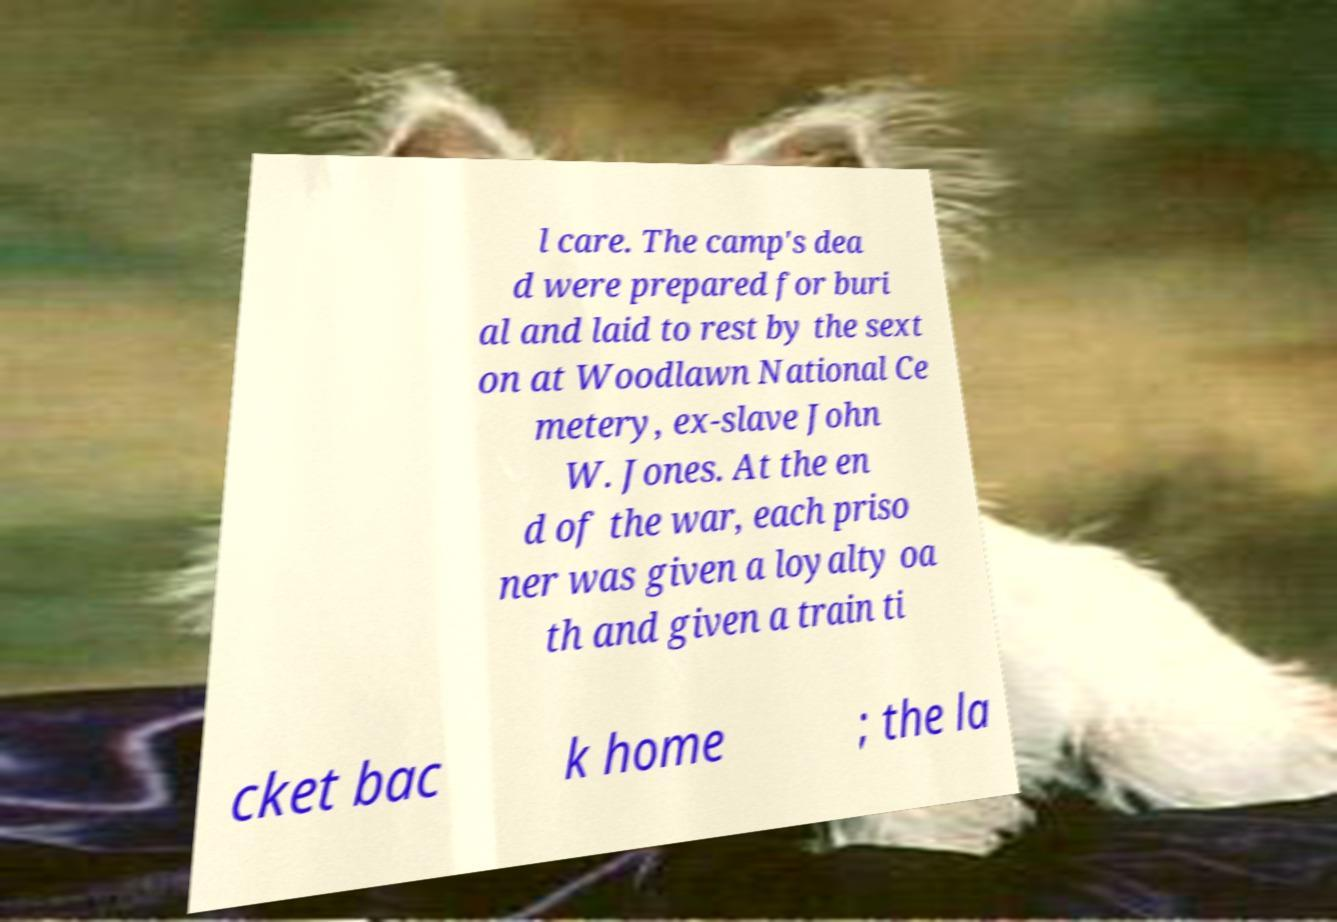Please read and relay the text visible in this image. What does it say? l care. The camp's dea d were prepared for buri al and laid to rest by the sext on at Woodlawn National Ce metery, ex-slave John W. Jones. At the en d of the war, each priso ner was given a loyalty oa th and given a train ti cket bac k home ; the la 